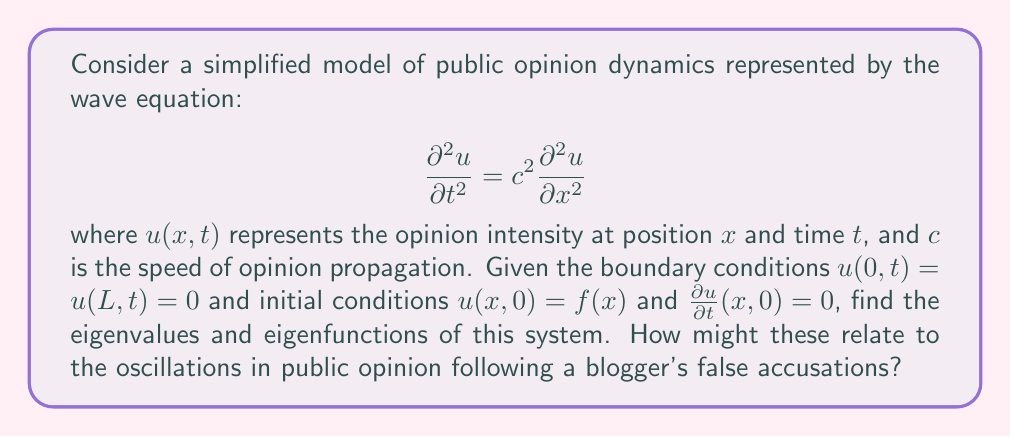Can you solve this math problem? To solve this eigenvalue problem, we follow these steps:

1) Separate variables: Let $u(x,t) = X(x)T(t)$

2) Substitute into the wave equation:
   $$X(x)T''(t) = c^2X''(x)T(t)$$

3) Divide both sides by $c^2X(x)T(t)$:
   $$\frac{T''(t)}{c^2T(t)} = \frac{X''(x)}{X(x)} = -\lambda$$
   where $\lambda$ is a constant (the eigenvalue).

4) This gives us two ODEs:
   $$T''(t) + \lambda c^2T(t) = 0$$
   $$X''(x) + \lambda X(x) = 0$$

5) The boundary conditions $u(0,t) = u(L,t) = 0$ translate to $X(0) = X(L) = 0$

6) Solving the spatial ODE with these boundary conditions gives:
   $$X_n(x) = \sin(\frac{n\pi x}{L}), \quad n = 1, 2, 3, ...$$

7) The corresponding eigenvalues are:
   $$\lambda_n = (\frac{n\pi}{L})^2, \quad n = 1, 2, 3, ...$$

8) The general solution is:
   $$u(x,t) = \sum_{n=1}^{\infty} (A_n \cos(\frac{n\pi c t}{L}) + B_n \sin(\frac{n\pi c t}{L})) \sin(\frac{n\pi x}{L})$$

9) The coefficients $A_n$ and $B_n$ are determined by the initial conditions.

In the context of public opinion following false accusations:
- Each eigenfunction represents a mode of opinion distribution.
- Lower modes (small $n$) represent broad, slowly changing opinions.
- Higher modes represent more localized, rapidly oscillating opinions.
- The eigenvalues determine the frequency of oscillation for each mode.
- The coefficients $A_n$ and $B_n$ represent the initial impact of the false accusations on each mode of public opinion.
Answer: Eigenvalues: $\lambda_n = (\frac{n\pi}{L})^2$, Eigenfunctions: $X_n(x) = \sin(\frac{n\pi x}{L})$, $n = 1, 2, 3, ...$ 